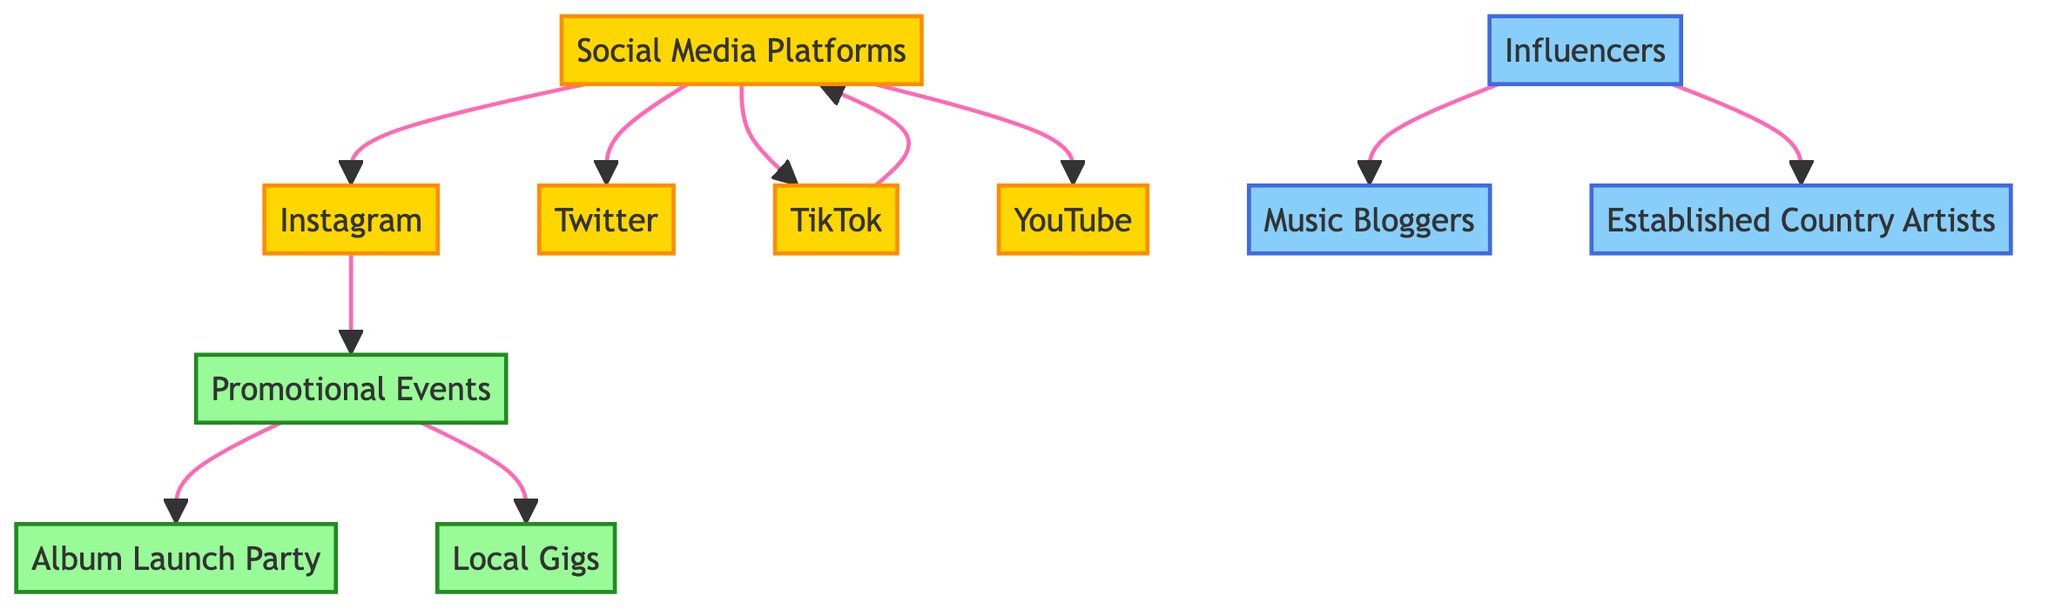What nodes are categorized as social media platforms? The question asks for the nodes that belong to the social media category. By analyzing the diagram, we see the nodes linked to "Social Media Platforms," which are Instagram, Twitter, TikTok, and YouTube.
Answer: Instagram, Twitter, TikTok, YouTube How many influencers are in the diagram? The question seeks to find the number of nodes identified as influencers. Upon reviewing the diagram, we find there are three influencer nodes: Music Bloggers, Country Artists, and the main Influencers node itself.
Answer: 3 What is the relationship between TikTok and Social Media Platforms? This question inquires about the connection or flow from one node to another. The diagram shows an edge pointing from TikTok to Social Media Platforms, indicating that TikTok is a subtype of Social Media Platforms.
Answer: TikTok is a social media platform Which promotional event is directly connected to influencers? The question looks for a promotional event that has a direct edge from the influencers node. Reviewing the promotional events connected to Influencers, we see that none are directly linked but rather Music Bloggers and Country Artists are influenced by them. Hence, the answer isn't a specific event but indicates the indirect influence.
Answer: None How many total edges are in the diagram? This question requests the total number of edges present connecting the nodes in the diagram. By counting all the individual connections made from one node to another, we find a total of 9 edges in the diagram.
Answer: 9 Which social media platform has a direct connection to promotional events? This question seeks to identify a social media platform that influences promotional events. From the review, Instagram is the only social media platform that has a direct connection to the Promotional Events node in the diagram.
Answer: Instagram What types of events are associated with the Promotional Events node? This question seeks to find the specific promotional events linked to the Promotional Events node. Analyzing the edges leading from Promotional Events, we identify two associated events: Album Launch Party and Local Gigs.
Answer: Album Launch Party, Local Gigs Which influencers are connected to Country Artists? This question asks for the influencers linked specifically to Country Artists. According to the directed edges, the Influencers node has an edge leading to Country Artists, indicating a direct connection.
Answer: Influencers 